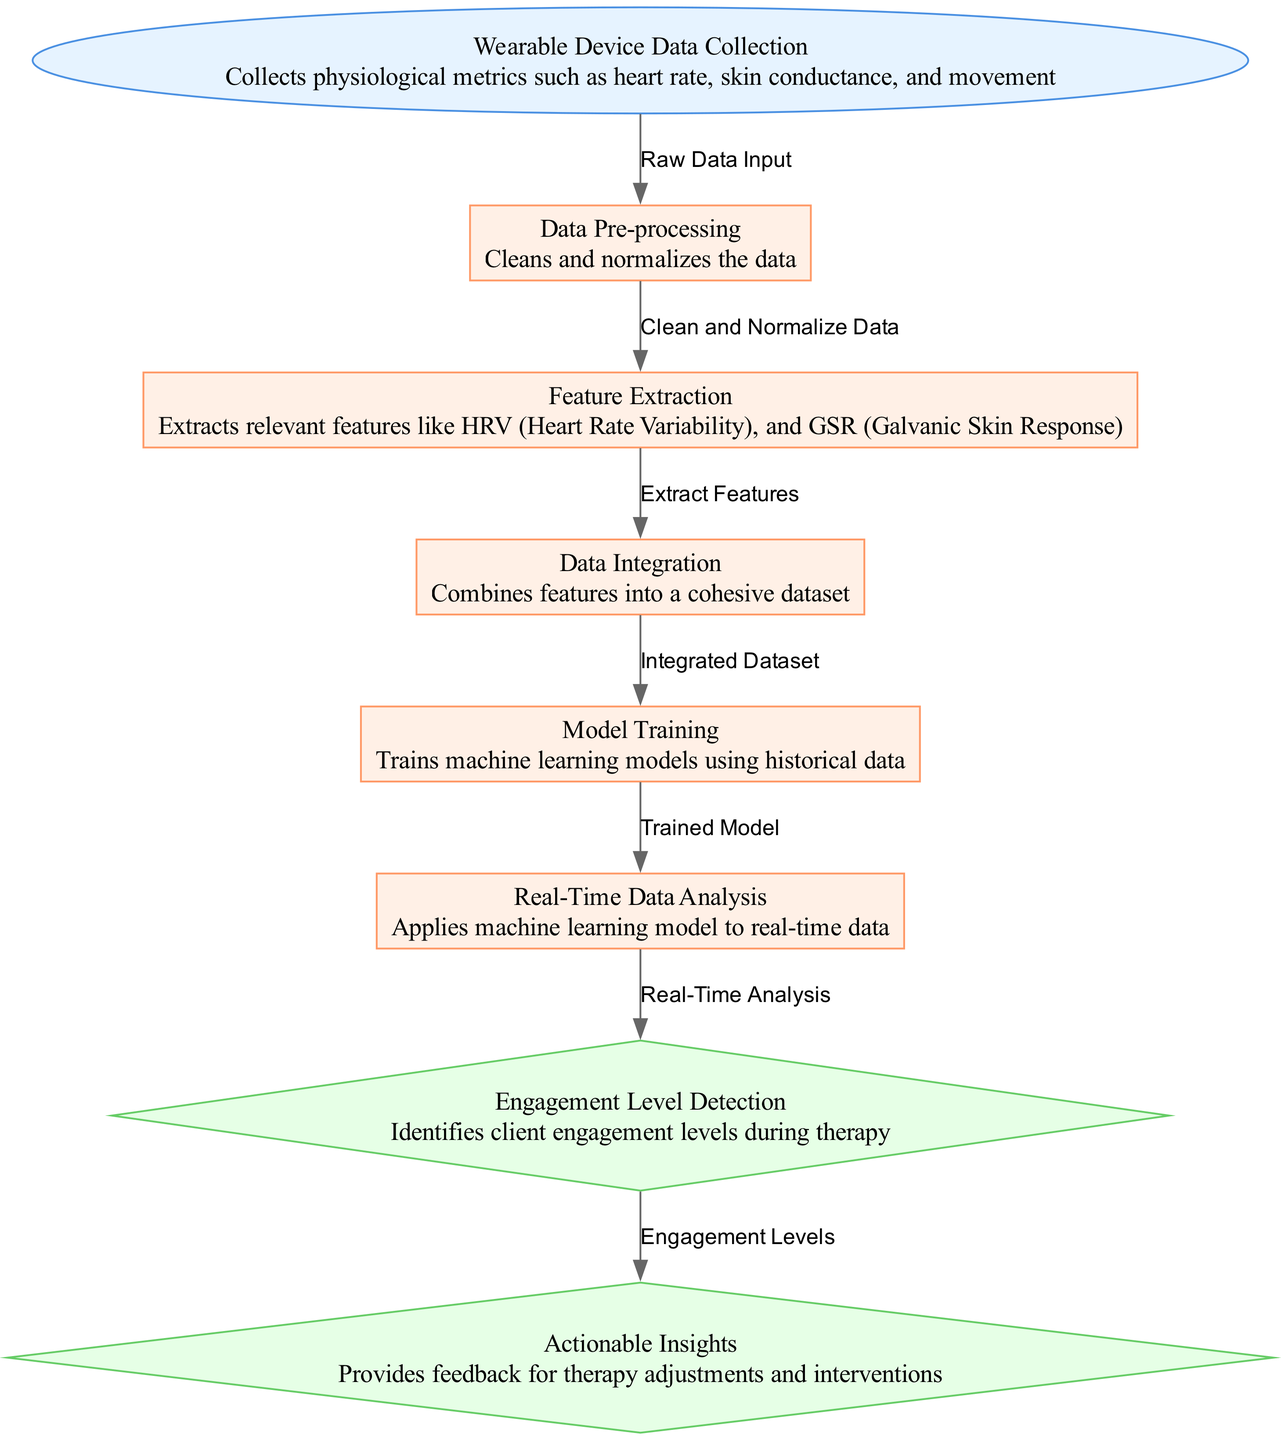What is the first node in the diagram? The first node, as indicated in the diagram, is where data collection starts, labeled "Wearable Device Data Collection." This is the initial point of the flowchart before any processing occurs.
Answer: Wearable Device Data Collection How many processing nodes are present in the diagram? By reviewing the diagram, it can be seen that there are four processing nodes: Data Pre-processing, Feature Extraction, Data Integration, and Model Training. Each of these nodes processes the data further in the machine learning pipeline.
Answer: Four What action occurs after Data Pre-processing? Looking at the flow, the node that follows Data Pre-processing is Feature Extraction. After the data is cleansed and normalized in the Pre-processing node, it moves onto extraction of features.
Answer: Feature Extraction What type of node is "Engagement Level Detection"? The diagram indicates that "Engagement Level Detection" is an output node, as it provides results from the processing, specifically identifying engagement levels during therapy sessions.
Answer: Output Which processed data is integrated into the model used in real-time analysis? The integrated dataset from the Data Integration node is fed into the Model Training node. This integrated dataset is what is trained to develop the model that is later utilized for real-time analysis.
Answer: Integrated Dataset What kind of insights does the last output node provide? The last output node in the diagram is Actionable Insights, which focuses on providing feedback for therapy adjustments and interventions, serving as practical outputs from the model's analysis.
Answer: Feedback for therapy adjustments How does real-time data get analyzed in this diagram? Real-time data is analyzed after being processed through the "Model Training" node, where the trained model is applied in the "Real-Time Data Analysis" node, assessing ongoing client engagement based on physiological metrics.
Answer: By applying the trained model What is the relationship between Engagement Level Detection and Actionable Insights? According to the flow of the diagram, Engagement Level Detection feeds directly into Actionable Insights, indicating that the identification of engagement levels informs what feedback and adjustments should be made in therapy.
Answer: Feedback and adjustments 